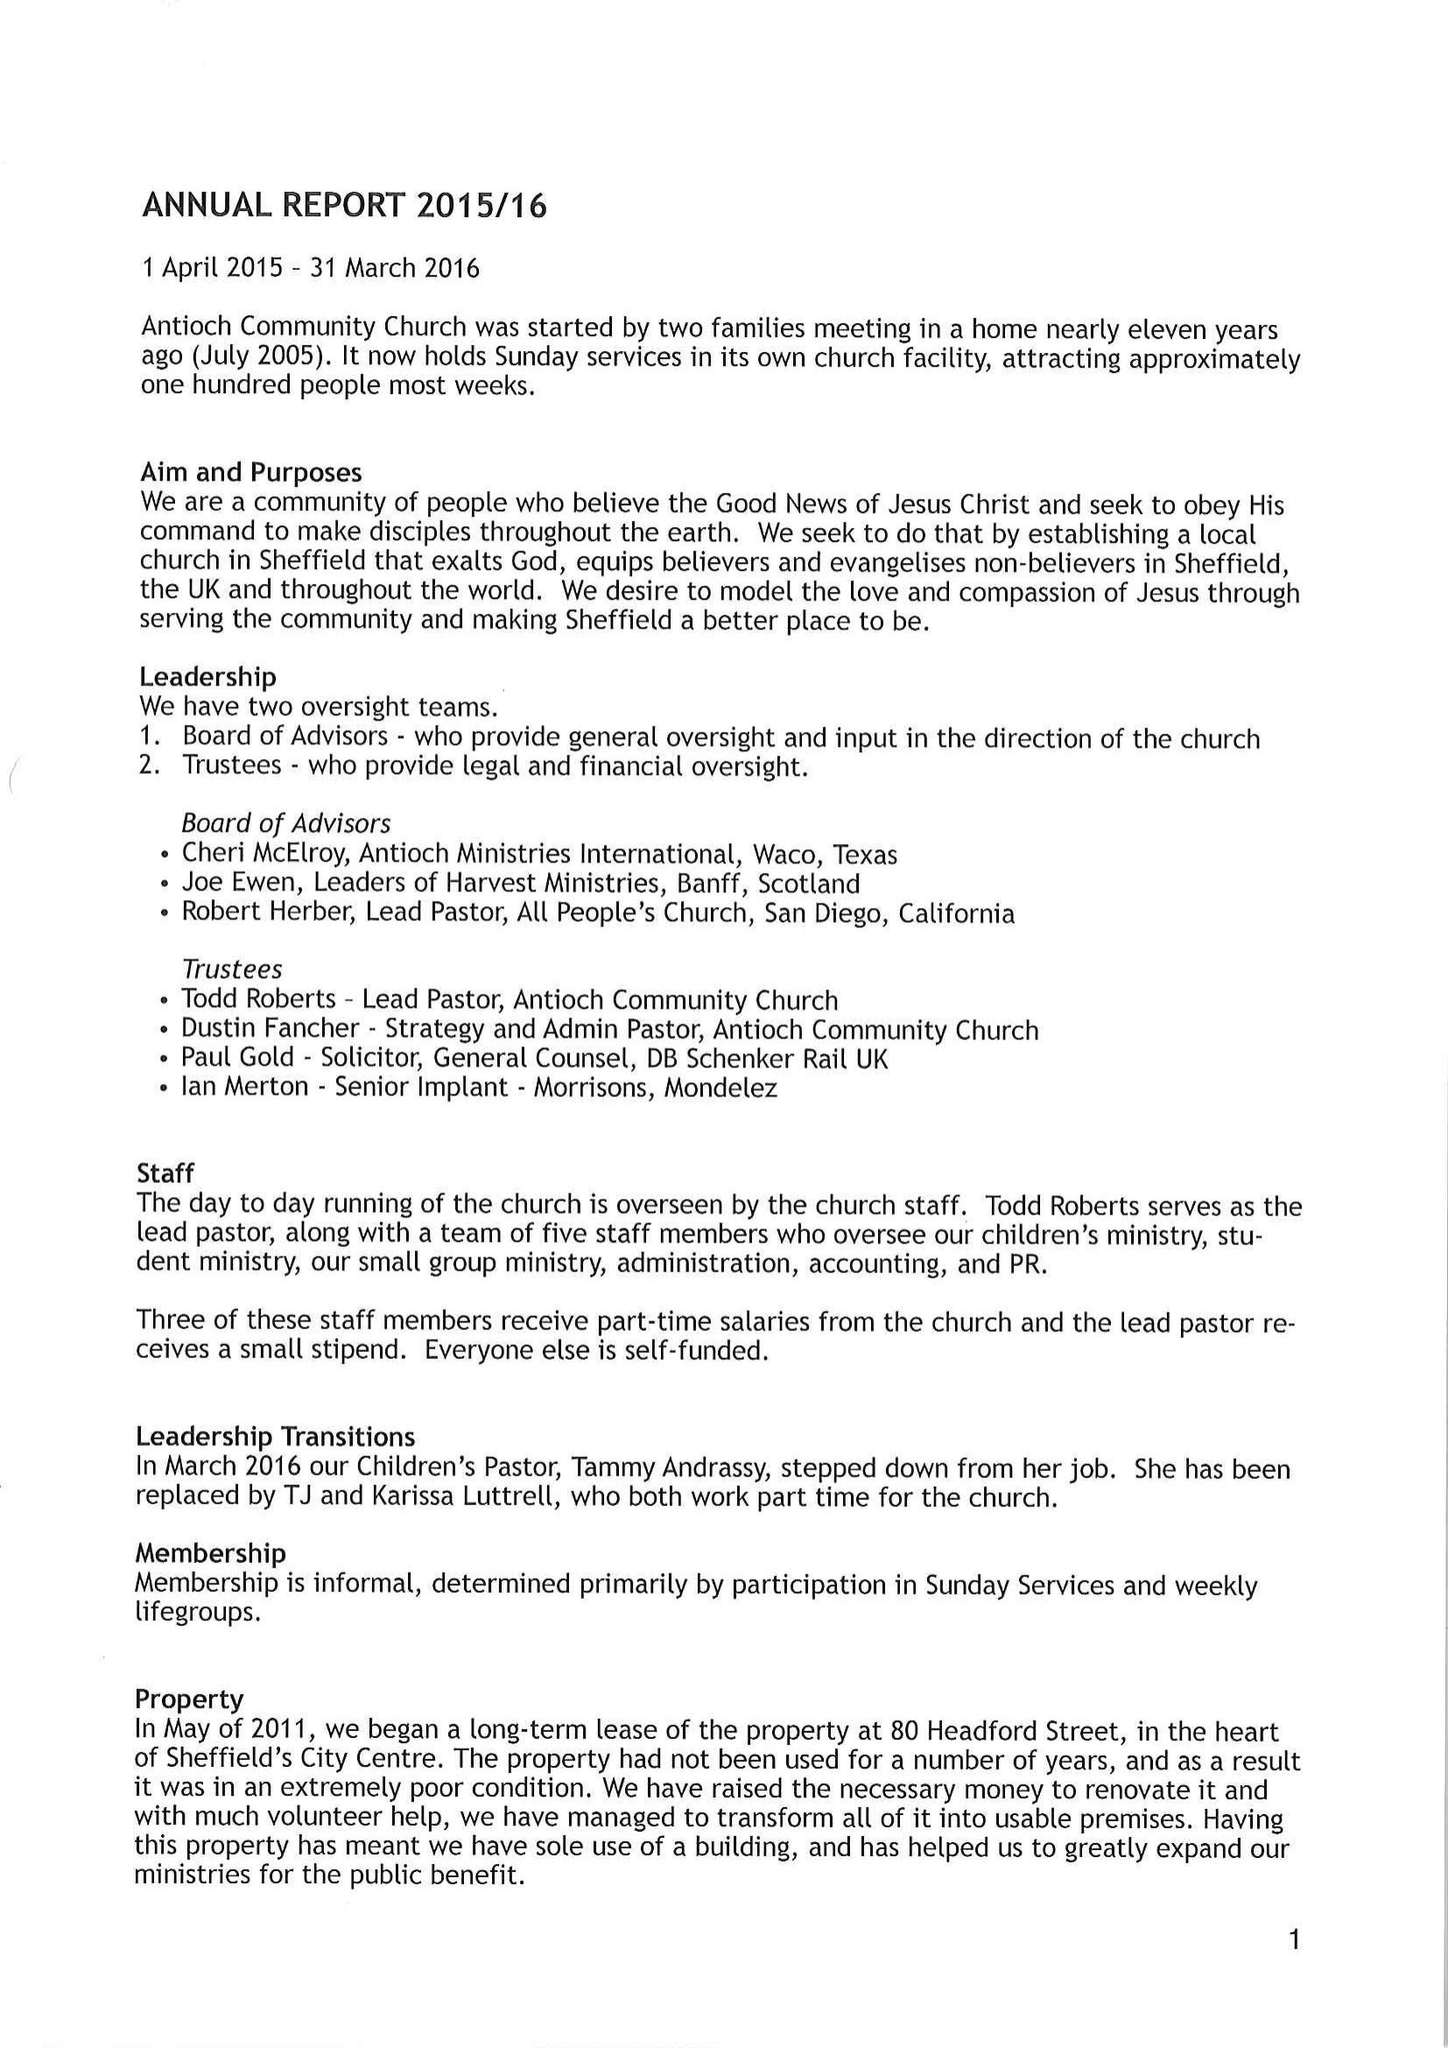What is the value for the spending_annually_in_british_pounds?
Answer the question using a single word or phrase. None 